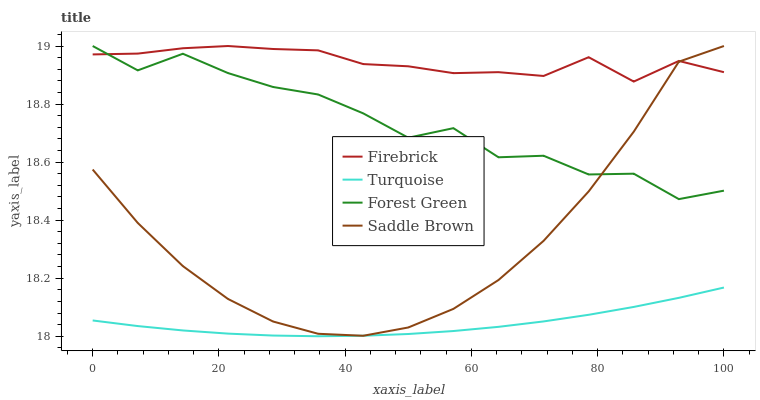Does Turquoise have the minimum area under the curve?
Answer yes or no. Yes. Does Firebrick have the maximum area under the curve?
Answer yes or no. Yes. Does Firebrick have the minimum area under the curve?
Answer yes or no. No. Does Turquoise have the maximum area under the curve?
Answer yes or no. No. Is Turquoise the smoothest?
Answer yes or no. Yes. Is Forest Green the roughest?
Answer yes or no. Yes. Is Firebrick the smoothest?
Answer yes or no. No. Is Firebrick the roughest?
Answer yes or no. No. Does Turquoise have the lowest value?
Answer yes or no. Yes. Does Firebrick have the lowest value?
Answer yes or no. No. Does Saddle Brown have the highest value?
Answer yes or no. Yes. Does Turquoise have the highest value?
Answer yes or no. No. Is Turquoise less than Firebrick?
Answer yes or no. Yes. Is Firebrick greater than Turquoise?
Answer yes or no. Yes. Does Firebrick intersect Saddle Brown?
Answer yes or no. Yes. Is Firebrick less than Saddle Brown?
Answer yes or no. No. Is Firebrick greater than Saddle Brown?
Answer yes or no. No. Does Turquoise intersect Firebrick?
Answer yes or no. No. 